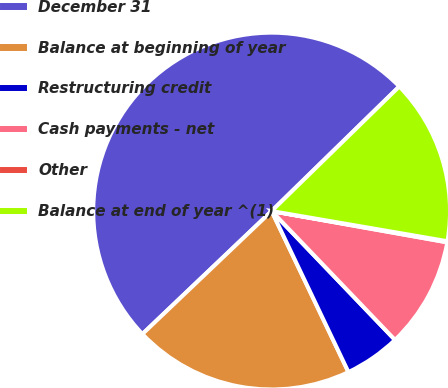Convert chart. <chart><loc_0><loc_0><loc_500><loc_500><pie_chart><fcel>December 31<fcel>Balance at beginning of year<fcel>Restructuring credit<fcel>Cash payments - net<fcel>Other<fcel>Balance at end of year ^(1)<nl><fcel>49.8%<fcel>19.98%<fcel>5.07%<fcel>10.04%<fcel>0.1%<fcel>15.01%<nl></chart> 